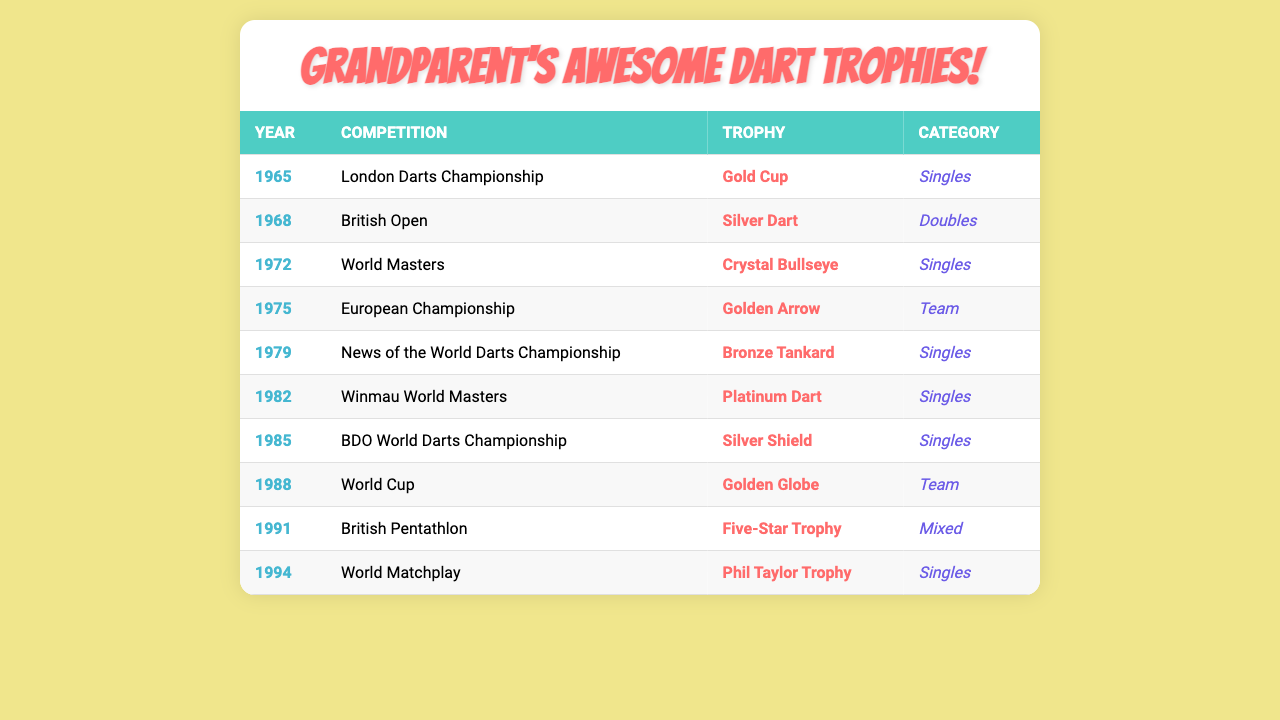What trophy did grandparent win in 1975? In the table, we look for the row where the year is 1975. It shows that the trophy won that year was the "Golden Arrow."
Answer: Golden Arrow Which competition awarded a Silver Dart? We can find the "Silver Dart" in the table and note the corresponding competition, which is the "British Open."
Answer: British Open How many trophies did grandparent win in the Singles category? By counting the rows where the category is "Singles," we find that there are 5 trophies: Gold Cup, Crystal Bullseye, Bronze Tankard, Platinum Dart, and Phil Taylor Trophy.
Answer: 5 Did grandparent ever win a trophy in a team competition? Checking the category for all rows in the table, we see that there is a trophy for the "European Championship" and the "World Cup," both categorized as Team. Thus, the answer is yes.
Answer: Yes What is the total number of competitions listed in the table? We can count the number of unique competitions listed in the table. There are 10 different competitions recorded, corresponding to each trophy year.
Answer: 10 In what year was the Five-Star Trophy won? In the table, we find the "Five-Star Trophy" and see it's associated with the year 1991.
Answer: 1991 What trophy did grandparent win last in the table? The last entry in the table corresponds to the year 1994, where the trophy won is the "Phil Taylor Trophy."
Answer: Phil Taylor Trophy Which trophy won in a doubles category? In the table, we look for the "Doubles" category and find there is a trophy called the "Silver Dart."
Answer: Silver Dart How many years are covered from the first to the last trophy? The first trophy is from 1965 and the last is from 1994. The difference in years is 1994 - 1965 = 29 years.
Answer: 29 years Was the trophy for the British Pentathlon won in a singles category? Looking at the entry for the "British Pentathlon," we see that it falls under the "Mixed" category, indicating no.
Answer: No 